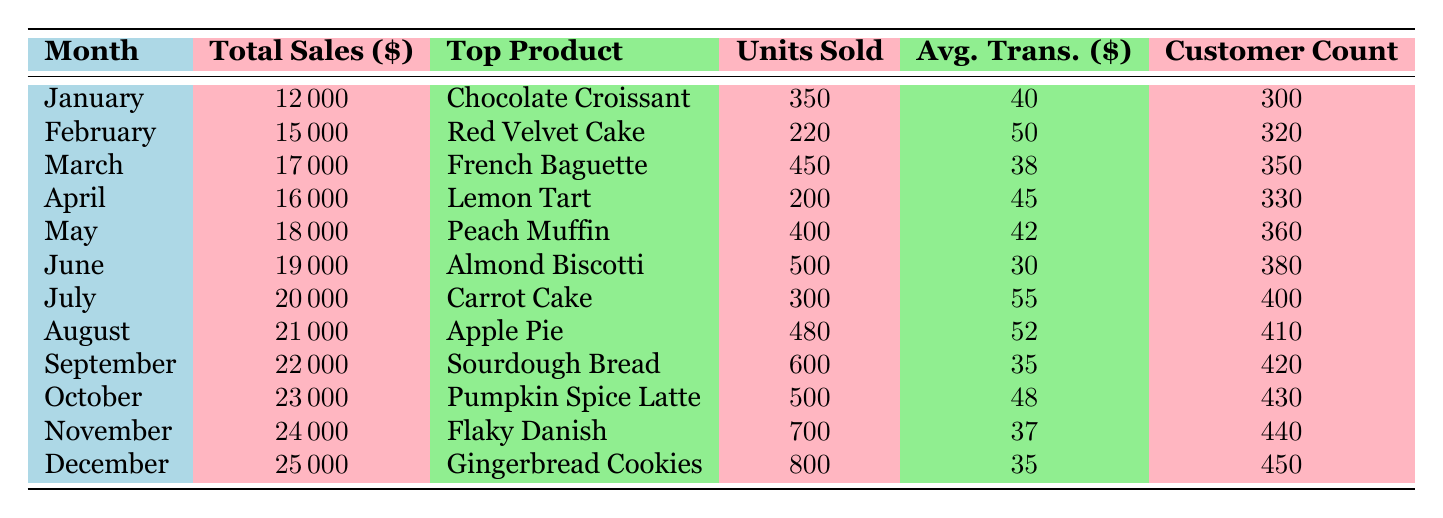What was the total sales in November? The total sales for November is provided directly in the table under the "Total Sales" column for the month of November. According to the table, it is 24000 dollars.
Answer: 24000 Which product had the highest sales in December? The table indicates that the top product for December is "Gingerbread Cookies," which is listed under the "Top Product" column for that month.
Answer: Gingerbread Cookies What is the average transaction value in March? The average transaction value for March can be found in the table under the "Avg. Trans." column for March, and it is 38 dollars.
Answer: 38 How many units of the Peach Muffin were sold in May? The units sold for the Peach Muffin in May are listed under the "Units Sold" column for that specific month, which is 400 units.
Answer: 400 Which month had the lowest total sales, and what was that amount? The month with the lowest total sales is January, with a total of 12000 dollars, as found in the "Total Sales" column.
Answer: January, 12000 What was the increase in total sales from January to December? The total sales in January were 12000 dollars, and in December, it was 25000 dollars. The increase can be calculated by subtracting January's sales from December's sales: 25000 - 12000 = 13000 dollars.
Answer: 13000 Is it true that more units of Flaky Danish were sold in November than Sourdough Bread in September? The table shows that 700 units of Flaky Danish were sold in November, while 600 units of Sourdough Bread were sold in September. Since 700 is greater than 600, the statement is true.
Answer: Yes What is the average customer count from March to June? To find the average customer count from March to June, sum the customer counts: 350 (March) + 360 (April) + 380 (May) + 400 (June) = 1490, then divide by the four months: 1490 / 4 = 372.5. The average is approximately 373.
Answer: 373 How many customers were served in total over the entire year? To find the total number of customers served over the year, sum the customer counts for each month: 300 + 320 + 350 + 330 + 360 + 380 + 400 + 410 + 420 + 430 + 440 + 450 = 4700 customers for the year.
Answer: 4700 What was the percentage increase in total sales from June to July? The total sales in June amount to 19000 dollars, and in July, it is 20000 dollars. The percentage increase can be calculated as: [(20000 - 19000) / 19000] * 100 = (1000 / 19000) * 100 ≈ 5.26%.
Answer: 5.26% 